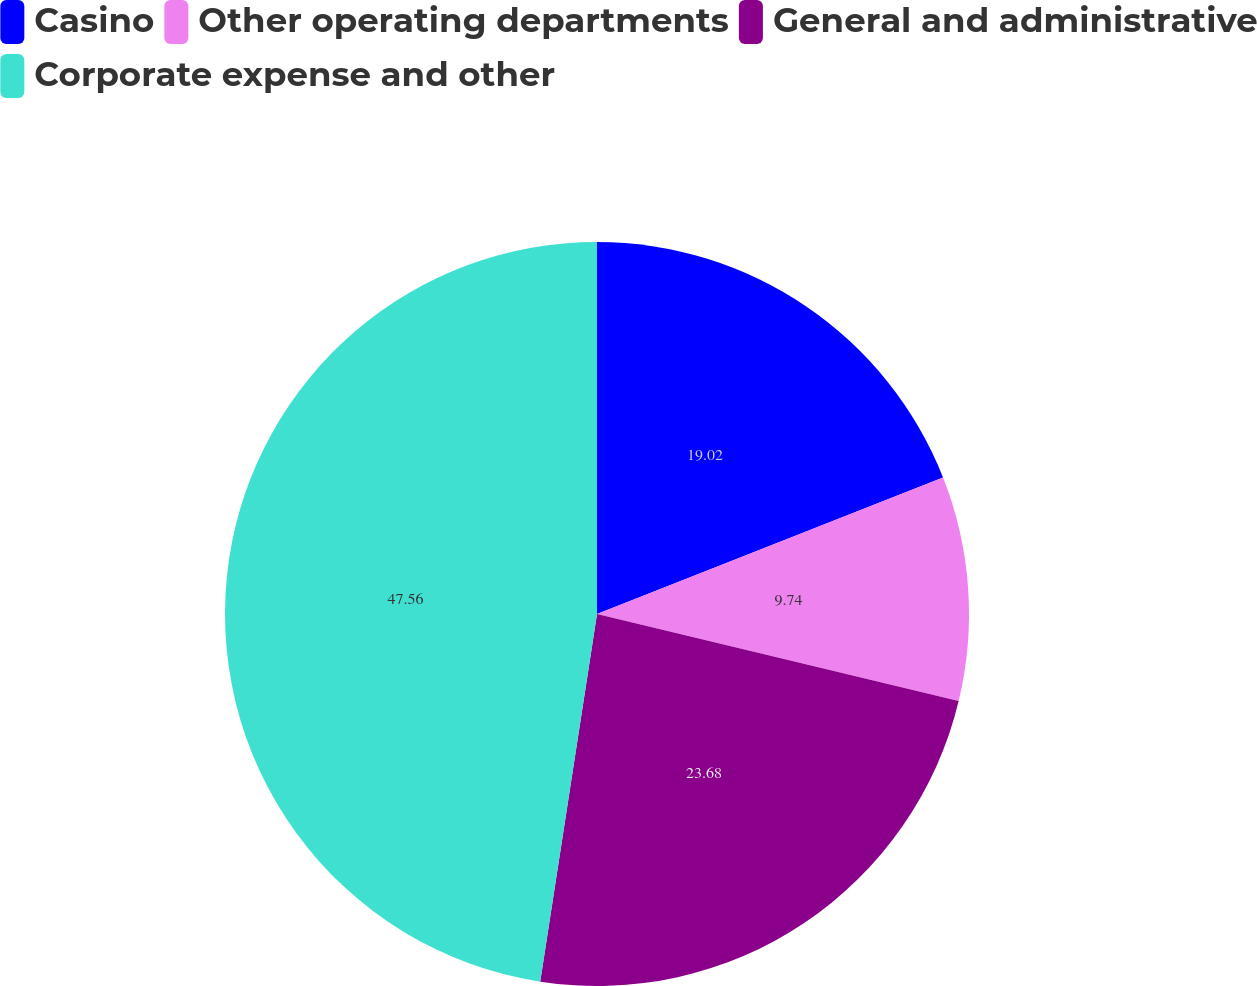Convert chart to OTSL. <chart><loc_0><loc_0><loc_500><loc_500><pie_chart><fcel>Casino<fcel>Other operating departments<fcel>General and administrative<fcel>Corporate expense and other<nl><fcel>19.02%<fcel>9.74%<fcel>23.68%<fcel>47.56%<nl></chart> 